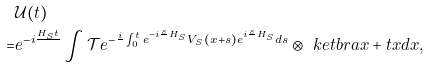<formula> <loc_0><loc_0><loc_500><loc_500>& \mathcal { U } ( t ) \\ = & e ^ { - i \frac { H _ { S } t } { } } \int \mathcal { T } e ^ { - \frac { i } { } \int _ { 0 } ^ { t } e ^ { - i \frac { s } { } H _ { S } } V _ { S } ( x + s ) e ^ { i \frac { s } { } H _ { S } } d s } \otimes \ k e t b r a { x + t } { x } d x ,</formula> 